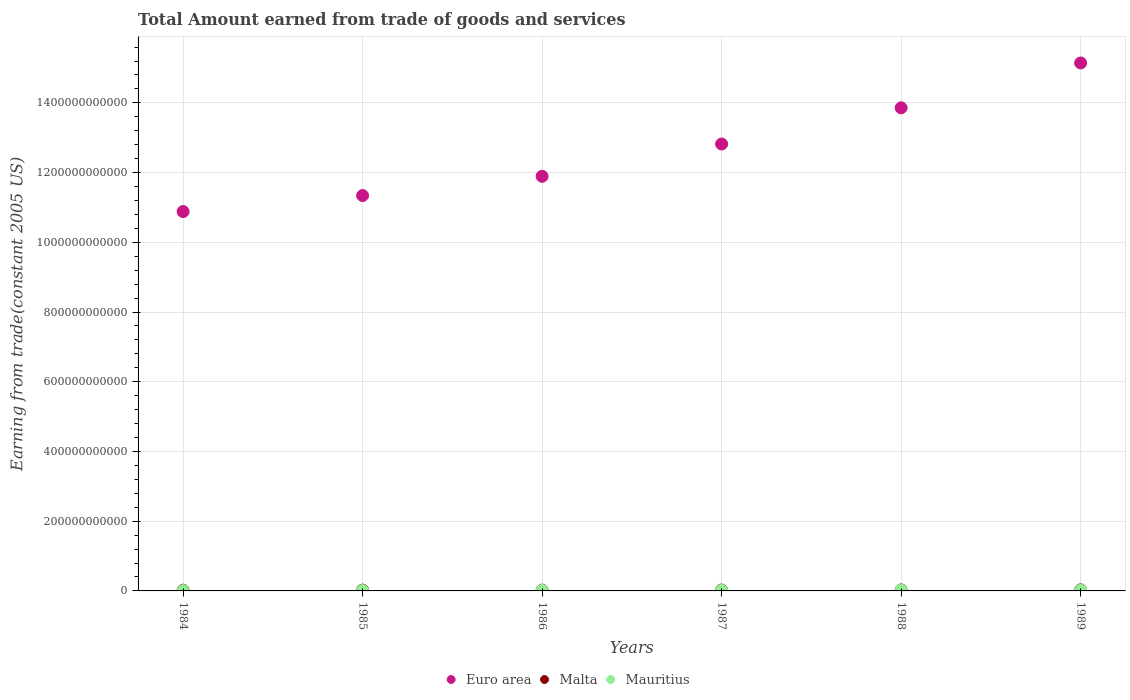Is the number of dotlines equal to the number of legend labels?
Provide a short and direct response. Yes. What is the total amount earned by trading goods and services in Mauritius in 1989?
Make the answer very short. 2.35e+09. Across all years, what is the maximum total amount earned by trading goods and services in Mauritius?
Give a very brief answer. 2.35e+09. Across all years, what is the minimum total amount earned by trading goods and services in Mauritius?
Keep it short and to the point. 1.04e+09. In which year was the total amount earned by trading goods and services in Euro area maximum?
Your answer should be very brief. 1989. In which year was the total amount earned by trading goods and services in Malta minimum?
Give a very brief answer. 1984. What is the total total amount earned by trading goods and services in Malta in the graph?
Offer a terse response. 1.49e+1. What is the difference between the total amount earned by trading goods and services in Malta in 1986 and that in 1989?
Provide a short and direct response. -8.62e+08. What is the difference between the total amount earned by trading goods and services in Euro area in 1985 and the total amount earned by trading goods and services in Mauritius in 1984?
Keep it short and to the point. 1.13e+12. What is the average total amount earned by trading goods and services in Malta per year?
Your response must be concise. 2.49e+09. In the year 1985, what is the difference between the total amount earned by trading goods and services in Euro area and total amount earned by trading goods and services in Mauritius?
Give a very brief answer. 1.13e+12. In how many years, is the total amount earned by trading goods and services in Euro area greater than 800000000000 US$?
Ensure brevity in your answer.  6. What is the ratio of the total amount earned by trading goods and services in Malta in 1984 to that in 1985?
Your answer should be compact. 0.92. Is the total amount earned by trading goods and services in Mauritius in 1987 less than that in 1989?
Offer a terse response. Yes. What is the difference between the highest and the second highest total amount earned by trading goods and services in Malta?
Provide a short and direct response. 3.09e+08. What is the difference between the highest and the lowest total amount earned by trading goods and services in Euro area?
Offer a very short reply. 4.26e+11. Does the total amount earned by trading goods and services in Mauritius monotonically increase over the years?
Provide a short and direct response. Yes. Is the total amount earned by trading goods and services in Malta strictly greater than the total amount earned by trading goods and services in Euro area over the years?
Ensure brevity in your answer.  No. Is the total amount earned by trading goods and services in Mauritius strictly less than the total amount earned by trading goods and services in Malta over the years?
Make the answer very short. Yes. What is the difference between two consecutive major ticks on the Y-axis?
Provide a succinct answer. 2.00e+11. Are the values on the major ticks of Y-axis written in scientific E-notation?
Offer a very short reply. No. Does the graph contain any zero values?
Make the answer very short. No. Does the graph contain grids?
Provide a short and direct response. Yes. Where does the legend appear in the graph?
Give a very brief answer. Bottom center. How are the legend labels stacked?
Offer a terse response. Horizontal. What is the title of the graph?
Provide a short and direct response. Total Amount earned from trade of goods and services. What is the label or title of the Y-axis?
Ensure brevity in your answer.  Earning from trade(constant 2005 US). What is the Earning from trade(constant 2005 US) in Euro area in 1984?
Offer a terse response. 1.09e+12. What is the Earning from trade(constant 2005 US) of Malta in 1984?
Keep it short and to the point. 2.05e+09. What is the Earning from trade(constant 2005 US) of Mauritius in 1984?
Provide a succinct answer. 1.04e+09. What is the Earning from trade(constant 2005 US) in Euro area in 1985?
Your answer should be very brief. 1.13e+12. What is the Earning from trade(constant 2005 US) of Malta in 1985?
Offer a very short reply. 2.23e+09. What is the Earning from trade(constant 2005 US) in Mauritius in 1985?
Make the answer very short. 1.11e+09. What is the Earning from trade(constant 2005 US) in Euro area in 1986?
Your response must be concise. 1.19e+12. What is the Earning from trade(constant 2005 US) in Malta in 1986?
Your answer should be very brief. 2.24e+09. What is the Earning from trade(constant 2005 US) of Mauritius in 1986?
Make the answer very short. 1.42e+09. What is the Earning from trade(constant 2005 US) of Euro area in 1987?
Give a very brief answer. 1.28e+12. What is the Earning from trade(constant 2005 US) in Malta in 1987?
Provide a short and direct response. 2.51e+09. What is the Earning from trade(constant 2005 US) of Mauritius in 1987?
Your answer should be very brief. 1.93e+09. What is the Earning from trade(constant 2005 US) of Euro area in 1988?
Offer a terse response. 1.39e+12. What is the Earning from trade(constant 2005 US) of Malta in 1988?
Keep it short and to the point. 2.79e+09. What is the Earning from trade(constant 2005 US) in Mauritius in 1988?
Provide a short and direct response. 2.31e+09. What is the Earning from trade(constant 2005 US) of Euro area in 1989?
Offer a very short reply. 1.51e+12. What is the Earning from trade(constant 2005 US) in Malta in 1989?
Your response must be concise. 3.10e+09. What is the Earning from trade(constant 2005 US) in Mauritius in 1989?
Keep it short and to the point. 2.35e+09. Across all years, what is the maximum Earning from trade(constant 2005 US) in Euro area?
Provide a succinct answer. 1.51e+12. Across all years, what is the maximum Earning from trade(constant 2005 US) of Malta?
Your answer should be very brief. 3.10e+09. Across all years, what is the maximum Earning from trade(constant 2005 US) in Mauritius?
Offer a terse response. 2.35e+09. Across all years, what is the minimum Earning from trade(constant 2005 US) of Euro area?
Make the answer very short. 1.09e+12. Across all years, what is the minimum Earning from trade(constant 2005 US) of Malta?
Your answer should be very brief. 2.05e+09. Across all years, what is the minimum Earning from trade(constant 2005 US) in Mauritius?
Your answer should be compact. 1.04e+09. What is the total Earning from trade(constant 2005 US) in Euro area in the graph?
Your answer should be compact. 7.59e+12. What is the total Earning from trade(constant 2005 US) in Malta in the graph?
Offer a very short reply. 1.49e+1. What is the total Earning from trade(constant 2005 US) of Mauritius in the graph?
Offer a very short reply. 1.02e+1. What is the difference between the Earning from trade(constant 2005 US) of Euro area in 1984 and that in 1985?
Ensure brevity in your answer.  -4.60e+1. What is the difference between the Earning from trade(constant 2005 US) of Malta in 1984 and that in 1985?
Your answer should be compact. -1.89e+08. What is the difference between the Earning from trade(constant 2005 US) of Mauritius in 1984 and that in 1985?
Make the answer very short. -7.17e+07. What is the difference between the Earning from trade(constant 2005 US) of Euro area in 1984 and that in 1986?
Ensure brevity in your answer.  -1.01e+11. What is the difference between the Earning from trade(constant 2005 US) of Malta in 1984 and that in 1986?
Your answer should be very brief. -1.90e+08. What is the difference between the Earning from trade(constant 2005 US) of Mauritius in 1984 and that in 1986?
Make the answer very short. -3.83e+08. What is the difference between the Earning from trade(constant 2005 US) of Euro area in 1984 and that in 1987?
Provide a short and direct response. -1.94e+11. What is the difference between the Earning from trade(constant 2005 US) in Malta in 1984 and that in 1987?
Give a very brief answer. -4.66e+08. What is the difference between the Earning from trade(constant 2005 US) of Mauritius in 1984 and that in 1987?
Your response must be concise. -8.89e+08. What is the difference between the Earning from trade(constant 2005 US) in Euro area in 1984 and that in 1988?
Keep it short and to the point. -2.98e+11. What is the difference between the Earning from trade(constant 2005 US) of Malta in 1984 and that in 1988?
Your response must be concise. -7.43e+08. What is the difference between the Earning from trade(constant 2005 US) in Mauritius in 1984 and that in 1988?
Ensure brevity in your answer.  -1.27e+09. What is the difference between the Earning from trade(constant 2005 US) in Euro area in 1984 and that in 1989?
Your answer should be very brief. -4.26e+11. What is the difference between the Earning from trade(constant 2005 US) of Malta in 1984 and that in 1989?
Your answer should be compact. -1.05e+09. What is the difference between the Earning from trade(constant 2005 US) of Mauritius in 1984 and that in 1989?
Your answer should be very brief. -1.31e+09. What is the difference between the Earning from trade(constant 2005 US) in Euro area in 1985 and that in 1986?
Your answer should be compact. -5.51e+1. What is the difference between the Earning from trade(constant 2005 US) in Malta in 1985 and that in 1986?
Your answer should be compact. -1.41e+06. What is the difference between the Earning from trade(constant 2005 US) of Mauritius in 1985 and that in 1986?
Ensure brevity in your answer.  -3.12e+08. What is the difference between the Earning from trade(constant 2005 US) in Euro area in 1985 and that in 1987?
Give a very brief answer. -1.48e+11. What is the difference between the Earning from trade(constant 2005 US) in Malta in 1985 and that in 1987?
Your response must be concise. -2.76e+08. What is the difference between the Earning from trade(constant 2005 US) of Mauritius in 1985 and that in 1987?
Keep it short and to the point. -8.17e+08. What is the difference between the Earning from trade(constant 2005 US) in Euro area in 1985 and that in 1988?
Ensure brevity in your answer.  -2.52e+11. What is the difference between the Earning from trade(constant 2005 US) of Malta in 1985 and that in 1988?
Provide a succinct answer. -5.54e+08. What is the difference between the Earning from trade(constant 2005 US) of Mauritius in 1985 and that in 1988?
Give a very brief answer. -1.20e+09. What is the difference between the Earning from trade(constant 2005 US) in Euro area in 1985 and that in 1989?
Provide a short and direct response. -3.80e+11. What is the difference between the Earning from trade(constant 2005 US) of Malta in 1985 and that in 1989?
Offer a terse response. -8.63e+08. What is the difference between the Earning from trade(constant 2005 US) of Mauritius in 1985 and that in 1989?
Provide a succinct answer. -1.24e+09. What is the difference between the Earning from trade(constant 2005 US) of Euro area in 1986 and that in 1987?
Make the answer very short. -9.27e+1. What is the difference between the Earning from trade(constant 2005 US) in Malta in 1986 and that in 1987?
Provide a succinct answer. -2.75e+08. What is the difference between the Earning from trade(constant 2005 US) in Mauritius in 1986 and that in 1987?
Provide a succinct answer. -5.06e+08. What is the difference between the Earning from trade(constant 2005 US) in Euro area in 1986 and that in 1988?
Your answer should be very brief. -1.97e+11. What is the difference between the Earning from trade(constant 2005 US) in Malta in 1986 and that in 1988?
Keep it short and to the point. -5.53e+08. What is the difference between the Earning from trade(constant 2005 US) in Mauritius in 1986 and that in 1988?
Your answer should be very brief. -8.90e+08. What is the difference between the Earning from trade(constant 2005 US) in Euro area in 1986 and that in 1989?
Your answer should be compact. -3.25e+11. What is the difference between the Earning from trade(constant 2005 US) of Malta in 1986 and that in 1989?
Provide a short and direct response. -8.62e+08. What is the difference between the Earning from trade(constant 2005 US) in Mauritius in 1986 and that in 1989?
Provide a short and direct response. -9.24e+08. What is the difference between the Earning from trade(constant 2005 US) of Euro area in 1987 and that in 1988?
Provide a short and direct response. -1.04e+11. What is the difference between the Earning from trade(constant 2005 US) in Malta in 1987 and that in 1988?
Offer a terse response. -2.78e+08. What is the difference between the Earning from trade(constant 2005 US) of Mauritius in 1987 and that in 1988?
Ensure brevity in your answer.  -3.84e+08. What is the difference between the Earning from trade(constant 2005 US) in Euro area in 1987 and that in 1989?
Provide a short and direct response. -2.32e+11. What is the difference between the Earning from trade(constant 2005 US) of Malta in 1987 and that in 1989?
Your answer should be very brief. -5.87e+08. What is the difference between the Earning from trade(constant 2005 US) of Mauritius in 1987 and that in 1989?
Offer a terse response. -4.19e+08. What is the difference between the Earning from trade(constant 2005 US) in Euro area in 1988 and that in 1989?
Ensure brevity in your answer.  -1.29e+11. What is the difference between the Earning from trade(constant 2005 US) in Malta in 1988 and that in 1989?
Ensure brevity in your answer.  -3.09e+08. What is the difference between the Earning from trade(constant 2005 US) of Mauritius in 1988 and that in 1989?
Your response must be concise. -3.47e+07. What is the difference between the Earning from trade(constant 2005 US) in Euro area in 1984 and the Earning from trade(constant 2005 US) in Malta in 1985?
Your answer should be very brief. 1.09e+12. What is the difference between the Earning from trade(constant 2005 US) in Euro area in 1984 and the Earning from trade(constant 2005 US) in Mauritius in 1985?
Provide a short and direct response. 1.09e+12. What is the difference between the Earning from trade(constant 2005 US) in Malta in 1984 and the Earning from trade(constant 2005 US) in Mauritius in 1985?
Your response must be concise. 9.33e+08. What is the difference between the Earning from trade(constant 2005 US) of Euro area in 1984 and the Earning from trade(constant 2005 US) of Malta in 1986?
Your answer should be compact. 1.09e+12. What is the difference between the Earning from trade(constant 2005 US) in Euro area in 1984 and the Earning from trade(constant 2005 US) in Mauritius in 1986?
Your response must be concise. 1.09e+12. What is the difference between the Earning from trade(constant 2005 US) in Malta in 1984 and the Earning from trade(constant 2005 US) in Mauritius in 1986?
Your response must be concise. 6.21e+08. What is the difference between the Earning from trade(constant 2005 US) of Euro area in 1984 and the Earning from trade(constant 2005 US) of Malta in 1987?
Ensure brevity in your answer.  1.09e+12. What is the difference between the Earning from trade(constant 2005 US) in Euro area in 1984 and the Earning from trade(constant 2005 US) in Mauritius in 1987?
Your answer should be very brief. 1.09e+12. What is the difference between the Earning from trade(constant 2005 US) of Malta in 1984 and the Earning from trade(constant 2005 US) of Mauritius in 1987?
Ensure brevity in your answer.  1.16e+08. What is the difference between the Earning from trade(constant 2005 US) of Euro area in 1984 and the Earning from trade(constant 2005 US) of Malta in 1988?
Your answer should be very brief. 1.09e+12. What is the difference between the Earning from trade(constant 2005 US) of Euro area in 1984 and the Earning from trade(constant 2005 US) of Mauritius in 1988?
Keep it short and to the point. 1.09e+12. What is the difference between the Earning from trade(constant 2005 US) in Malta in 1984 and the Earning from trade(constant 2005 US) in Mauritius in 1988?
Make the answer very short. -2.68e+08. What is the difference between the Earning from trade(constant 2005 US) of Euro area in 1984 and the Earning from trade(constant 2005 US) of Malta in 1989?
Give a very brief answer. 1.09e+12. What is the difference between the Earning from trade(constant 2005 US) in Euro area in 1984 and the Earning from trade(constant 2005 US) in Mauritius in 1989?
Your response must be concise. 1.09e+12. What is the difference between the Earning from trade(constant 2005 US) in Malta in 1984 and the Earning from trade(constant 2005 US) in Mauritius in 1989?
Your answer should be very brief. -3.03e+08. What is the difference between the Earning from trade(constant 2005 US) in Euro area in 1985 and the Earning from trade(constant 2005 US) in Malta in 1986?
Give a very brief answer. 1.13e+12. What is the difference between the Earning from trade(constant 2005 US) in Euro area in 1985 and the Earning from trade(constant 2005 US) in Mauritius in 1986?
Your answer should be very brief. 1.13e+12. What is the difference between the Earning from trade(constant 2005 US) of Malta in 1985 and the Earning from trade(constant 2005 US) of Mauritius in 1986?
Give a very brief answer. 8.10e+08. What is the difference between the Earning from trade(constant 2005 US) of Euro area in 1985 and the Earning from trade(constant 2005 US) of Malta in 1987?
Your answer should be compact. 1.13e+12. What is the difference between the Earning from trade(constant 2005 US) of Euro area in 1985 and the Earning from trade(constant 2005 US) of Mauritius in 1987?
Ensure brevity in your answer.  1.13e+12. What is the difference between the Earning from trade(constant 2005 US) in Malta in 1985 and the Earning from trade(constant 2005 US) in Mauritius in 1987?
Give a very brief answer. 3.05e+08. What is the difference between the Earning from trade(constant 2005 US) in Euro area in 1985 and the Earning from trade(constant 2005 US) in Malta in 1988?
Give a very brief answer. 1.13e+12. What is the difference between the Earning from trade(constant 2005 US) of Euro area in 1985 and the Earning from trade(constant 2005 US) of Mauritius in 1988?
Ensure brevity in your answer.  1.13e+12. What is the difference between the Earning from trade(constant 2005 US) of Malta in 1985 and the Earning from trade(constant 2005 US) of Mauritius in 1988?
Provide a short and direct response. -7.92e+07. What is the difference between the Earning from trade(constant 2005 US) in Euro area in 1985 and the Earning from trade(constant 2005 US) in Malta in 1989?
Offer a very short reply. 1.13e+12. What is the difference between the Earning from trade(constant 2005 US) of Euro area in 1985 and the Earning from trade(constant 2005 US) of Mauritius in 1989?
Offer a terse response. 1.13e+12. What is the difference between the Earning from trade(constant 2005 US) of Malta in 1985 and the Earning from trade(constant 2005 US) of Mauritius in 1989?
Provide a succinct answer. -1.14e+08. What is the difference between the Earning from trade(constant 2005 US) of Euro area in 1986 and the Earning from trade(constant 2005 US) of Malta in 1987?
Make the answer very short. 1.19e+12. What is the difference between the Earning from trade(constant 2005 US) in Euro area in 1986 and the Earning from trade(constant 2005 US) in Mauritius in 1987?
Keep it short and to the point. 1.19e+12. What is the difference between the Earning from trade(constant 2005 US) in Malta in 1986 and the Earning from trade(constant 2005 US) in Mauritius in 1987?
Offer a terse response. 3.06e+08. What is the difference between the Earning from trade(constant 2005 US) in Euro area in 1986 and the Earning from trade(constant 2005 US) in Malta in 1988?
Keep it short and to the point. 1.19e+12. What is the difference between the Earning from trade(constant 2005 US) in Euro area in 1986 and the Earning from trade(constant 2005 US) in Mauritius in 1988?
Keep it short and to the point. 1.19e+12. What is the difference between the Earning from trade(constant 2005 US) of Malta in 1986 and the Earning from trade(constant 2005 US) of Mauritius in 1988?
Provide a succinct answer. -7.78e+07. What is the difference between the Earning from trade(constant 2005 US) of Euro area in 1986 and the Earning from trade(constant 2005 US) of Malta in 1989?
Your response must be concise. 1.19e+12. What is the difference between the Earning from trade(constant 2005 US) of Euro area in 1986 and the Earning from trade(constant 2005 US) of Mauritius in 1989?
Your answer should be very brief. 1.19e+12. What is the difference between the Earning from trade(constant 2005 US) of Malta in 1986 and the Earning from trade(constant 2005 US) of Mauritius in 1989?
Your response must be concise. -1.12e+08. What is the difference between the Earning from trade(constant 2005 US) of Euro area in 1987 and the Earning from trade(constant 2005 US) of Malta in 1988?
Ensure brevity in your answer.  1.28e+12. What is the difference between the Earning from trade(constant 2005 US) in Euro area in 1987 and the Earning from trade(constant 2005 US) in Mauritius in 1988?
Provide a short and direct response. 1.28e+12. What is the difference between the Earning from trade(constant 2005 US) of Malta in 1987 and the Earning from trade(constant 2005 US) of Mauritius in 1988?
Offer a very short reply. 1.97e+08. What is the difference between the Earning from trade(constant 2005 US) in Euro area in 1987 and the Earning from trade(constant 2005 US) in Malta in 1989?
Your answer should be very brief. 1.28e+12. What is the difference between the Earning from trade(constant 2005 US) in Euro area in 1987 and the Earning from trade(constant 2005 US) in Mauritius in 1989?
Your answer should be very brief. 1.28e+12. What is the difference between the Earning from trade(constant 2005 US) in Malta in 1987 and the Earning from trade(constant 2005 US) in Mauritius in 1989?
Your response must be concise. 1.63e+08. What is the difference between the Earning from trade(constant 2005 US) in Euro area in 1988 and the Earning from trade(constant 2005 US) in Malta in 1989?
Your response must be concise. 1.38e+12. What is the difference between the Earning from trade(constant 2005 US) in Euro area in 1988 and the Earning from trade(constant 2005 US) in Mauritius in 1989?
Your response must be concise. 1.38e+12. What is the difference between the Earning from trade(constant 2005 US) in Malta in 1988 and the Earning from trade(constant 2005 US) in Mauritius in 1989?
Offer a terse response. 4.41e+08. What is the average Earning from trade(constant 2005 US) in Euro area per year?
Provide a short and direct response. 1.27e+12. What is the average Earning from trade(constant 2005 US) of Malta per year?
Provide a succinct answer. 2.49e+09. What is the average Earning from trade(constant 2005 US) of Mauritius per year?
Ensure brevity in your answer.  1.69e+09. In the year 1984, what is the difference between the Earning from trade(constant 2005 US) in Euro area and Earning from trade(constant 2005 US) in Malta?
Your answer should be compact. 1.09e+12. In the year 1984, what is the difference between the Earning from trade(constant 2005 US) of Euro area and Earning from trade(constant 2005 US) of Mauritius?
Keep it short and to the point. 1.09e+12. In the year 1984, what is the difference between the Earning from trade(constant 2005 US) of Malta and Earning from trade(constant 2005 US) of Mauritius?
Your answer should be very brief. 1.00e+09. In the year 1985, what is the difference between the Earning from trade(constant 2005 US) in Euro area and Earning from trade(constant 2005 US) in Malta?
Give a very brief answer. 1.13e+12. In the year 1985, what is the difference between the Earning from trade(constant 2005 US) of Euro area and Earning from trade(constant 2005 US) of Mauritius?
Your response must be concise. 1.13e+12. In the year 1985, what is the difference between the Earning from trade(constant 2005 US) in Malta and Earning from trade(constant 2005 US) in Mauritius?
Provide a short and direct response. 1.12e+09. In the year 1986, what is the difference between the Earning from trade(constant 2005 US) in Euro area and Earning from trade(constant 2005 US) in Malta?
Your response must be concise. 1.19e+12. In the year 1986, what is the difference between the Earning from trade(constant 2005 US) of Euro area and Earning from trade(constant 2005 US) of Mauritius?
Your answer should be compact. 1.19e+12. In the year 1986, what is the difference between the Earning from trade(constant 2005 US) of Malta and Earning from trade(constant 2005 US) of Mauritius?
Keep it short and to the point. 8.12e+08. In the year 1987, what is the difference between the Earning from trade(constant 2005 US) in Euro area and Earning from trade(constant 2005 US) in Malta?
Your answer should be very brief. 1.28e+12. In the year 1987, what is the difference between the Earning from trade(constant 2005 US) in Euro area and Earning from trade(constant 2005 US) in Mauritius?
Your response must be concise. 1.28e+12. In the year 1987, what is the difference between the Earning from trade(constant 2005 US) of Malta and Earning from trade(constant 2005 US) of Mauritius?
Offer a very short reply. 5.81e+08. In the year 1988, what is the difference between the Earning from trade(constant 2005 US) of Euro area and Earning from trade(constant 2005 US) of Malta?
Your answer should be very brief. 1.38e+12. In the year 1988, what is the difference between the Earning from trade(constant 2005 US) of Euro area and Earning from trade(constant 2005 US) of Mauritius?
Make the answer very short. 1.38e+12. In the year 1988, what is the difference between the Earning from trade(constant 2005 US) in Malta and Earning from trade(constant 2005 US) in Mauritius?
Your answer should be compact. 4.75e+08. In the year 1989, what is the difference between the Earning from trade(constant 2005 US) in Euro area and Earning from trade(constant 2005 US) in Malta?
Provide a short and direct response. 1.51e+12. In the year 1989, what is the difference between the Earning from trade(constant 2005 US) in Euro area and Earning from trade(constant 2005 US) in Mauritius?
Provide a short and direct response. 1.51e+12. In the year 1989, what is the difference between the Earning from trade(constant 2005 US) of Malta and Earning from trade(constant 2005 US) of Mauritius?
Provide a succinct answer. 7.49e+08. What is the ratio of the Earning from trade(constant 2005 US) in Euro area in 1984 to that in 1985?
Provide a succinct answer. 0.96. What is the ratio of the Earning from trade(constant 2005 US) of Malta in 1984 to that in 1985?
Your answer should be very brief. 0.92. What is the ratio of the Earning from trade(constant 2005 US) of Mauritius in 1984 to that in 1985?
Your response must be concise. 0.94. What is the ratio of the Earning from trade(constant 2005 US) in Euro area in 1984 to that in 1986?
Provide a succinct answer. 0.92. What is the ratio of the Earning from trade(constant 2005 US) in Malta in 1984 to that in 1986?
Provide a succinct answer. 0.91. What is the ratio of the Earning from trade(constant 2005 US) of Mauritius in 1984 to that in 1986?
Your answer should be very brief. 0.73. What is the ratio of the Earning from trade(constant 2005 US) in Euro area in 1984 to that in 1987?
Offer a terse response. 0.85. What is the ratio of the Earning from trade(constant 2005 US) of Malta in 1984 to that in 1987?
Ensure brevity in your answer.  0.81. What is the ratio of the Earning from trade(constant 2005 US) in Mauritius in 1984 to that in 1987?
Offer a terse response. 0.54. What is the ratio of the Earning from trade(constant 2005 US) of Euro area in 1984 to that in 1988?
Your response must be concise. 0.79. What is the ratio of the Earning from trade(constant 2005 US) in Malta in 1984 to that in 1988?
Give a very brief answer. 0.73. What is the ratio of the Earning from trade(constant 2005 US) in Mauritius in 1984 to that in 1988?
Your response must be concise. 0.45. What is the ratio of the Earning from trade(constant 2005 US) of Euro area in 1984 to that in 1989?
Ensure brevity in your answer.  0.72. What is the ratio of the Earning from trade(constant 2005 US) of Malta in 1984 to that in 1989?
Provide a short and direct response. 0.66. What is the ratio of the Earning from trade(constant 2005 US) of Mauritius in 1984 to that in 1989?
Keep it short and to the point. 0.44. What is the ratio of the Earning from trade(constant 2005 US) in Euro area in 1985 to that in 1986?
Give a very brief answer. 0.95. What is the ratio of the Earning from trade(constant 2005 US) in Malta in 1985 to that in 1986?
Make the answer very short. 1. What is the ratio of the Earning from trade(constant 2005 US) in Mauritius in 1985 to that in 1986?
Offer a very short reply. 0.78. What is the ratio of the Earning from trade(constant 2005 US) of Euro area in 1985 to that in 1987?
Offer a very short reply. 0.88. What is the ratio of the Earning from trade(constant 2005 US) in Malta in 1985 to that in 1987?
Offer a very short reply. 0.89. What is the ratio of the Earning from trade(constant 2005 US) in Mauritius in 1985 to that in 1987?
Offer a terse response. 0.58. What is the ratio of the Earning from trade(constant 2005 US) in Euro area in 1985 to that in 1988?
Provide a short and direct response. 0.82. What is the ratio of the Earning from trade(constant 2005 US) in Malta in 1985 to that in 1988?
Provide a short and direct response. 0.8. What is the ratio of the Earning from trade(constant 2005 US) of Mauritius in 1985 to that in 1988?
Give a very brief answer. 0.48. What is the ratio of the Earning from trade(constant 2005 US) in Euro area in 1985 to that in 1989?
Offer a terse response. 0.75. What is the ratio of the Earning from trade(constant 2005 US) of Malta in 1985 to that in 1989?
Keep it short and to the point. 0.72. What is the ratio of the Earning from trade(constant 2005 US) of Mauritius in 1985 to that in 1989?
Keep it short and to the point. 0.47. What is the ratio of the Earning from trade(constant 2005 US) of Euro area in 1986 to that in 1987?
Provide a short and direct response. 0.93. What is the ratio of the Earning from trade(constant 2005 US) of Malta in 1986 to that in 1987?
Provide a short and direct response. 0.89. What is the ratio of the Earning from trade(constant 2005 US) in Mauritius in 1986 to that in 1987?
Give a very brief answer. 0.74. What is the ratio of the Earning from trade(constant 2005 US) in Euro area in 1986 to that in 1988?
Provide a succinct answer. 0.86. What is the ratio of the Earning from trade(constant 2005 US) in Malta in 1986 to that in 1988?
Give a very brief answer. 0.8. What is the ratio of the Earning from trade(constant 2005 US) of Mauritius in 1986 to that in 1988?
Provide a short and direct response. 0.62. What is the ratio of the Earning from trade(constant 2005 US) in Euro area in 1986 to that in 1989?
Ensure brevity in your answer.  0.79. What is the ratio of the Earning from trade(constant 2005 US) in Malta in 1986 to that in 1989?
Your response must be concise. 0.72. What is the ratio of the Earning from trade(constant 2005 US) of Mauritius in 1986 to that in 1989?
Offer a very short reply. 0.61. What is the ratio of the Earning from trade(constant 2005 US) of Euro area in 1987 to that in 1988?
Give a very brief answer. 0.93. What is the ratio of the Earning from trade(constant 2005 US) in Malta in 1987 to that in 1988?
Offer a terse response. 0.9. What is the ratio of the Earning from trade(constant 2005 US) of Mauritius in 1987 to that in 1988?
Offer a very short reply. 0.83. What is the ratio of the Earning from trade(constant 2005 US) in Euro area in 1987 to that in 1989?
Your response must be concise. 0.85. What is the ratio of the Earning from trade(constant 2005 US) of Malta in 1987 to that in 1989?
Your response must be concise. 0.81. What is the ratio of the Earning from trade(constant 2005 US) in Mauritius in 1987 to that in 1989?
Provide a short and direct response. 0.82. What is the ratio of the Earning from trade(constant 2005 US) in Euro area in 1988 to that in 1989?
Ensure brevity in your answer.  0.92. What is the ratio of the Earning from trade(constant 2005 US) of Malta in 1988 to that in 1989?
Make the answer very short. 0.9. What is the ratio of the Earning from trade(constant 2005 US) in Mauritius in 1988 to that in 1989?
Ensure brevity in your answer.  0.99. What is the difference between the highest and the second highest Earning from trade(constant 2005 US) in Euro area?
Offer a terse response. 1.29e+11. What is the difference between the highest and the second highest Earning from trade(constant 2005 US) in Malta?
Offer a terse response. 3.09e+08. What is the difference between the highest and the second highest Earning from trade(constant 2005 US) of Mauritius?
Provide a succinct answer. 3.47e+07. What is the difference between the highest and the lowest Earning from trade(constant 2005 US) of Euro area?
Your response must be concise. 4.26e+11. What is the difference between the highest and the lowest Earning from trade(constant 2005 US) of Malta?
Provide a short and direct response. 1.05e+09. What is the difference between the highest and the lowest Earning from trade(constant 2005 US) of Mauritius?
Make the answer very short. 1.31e+09. 